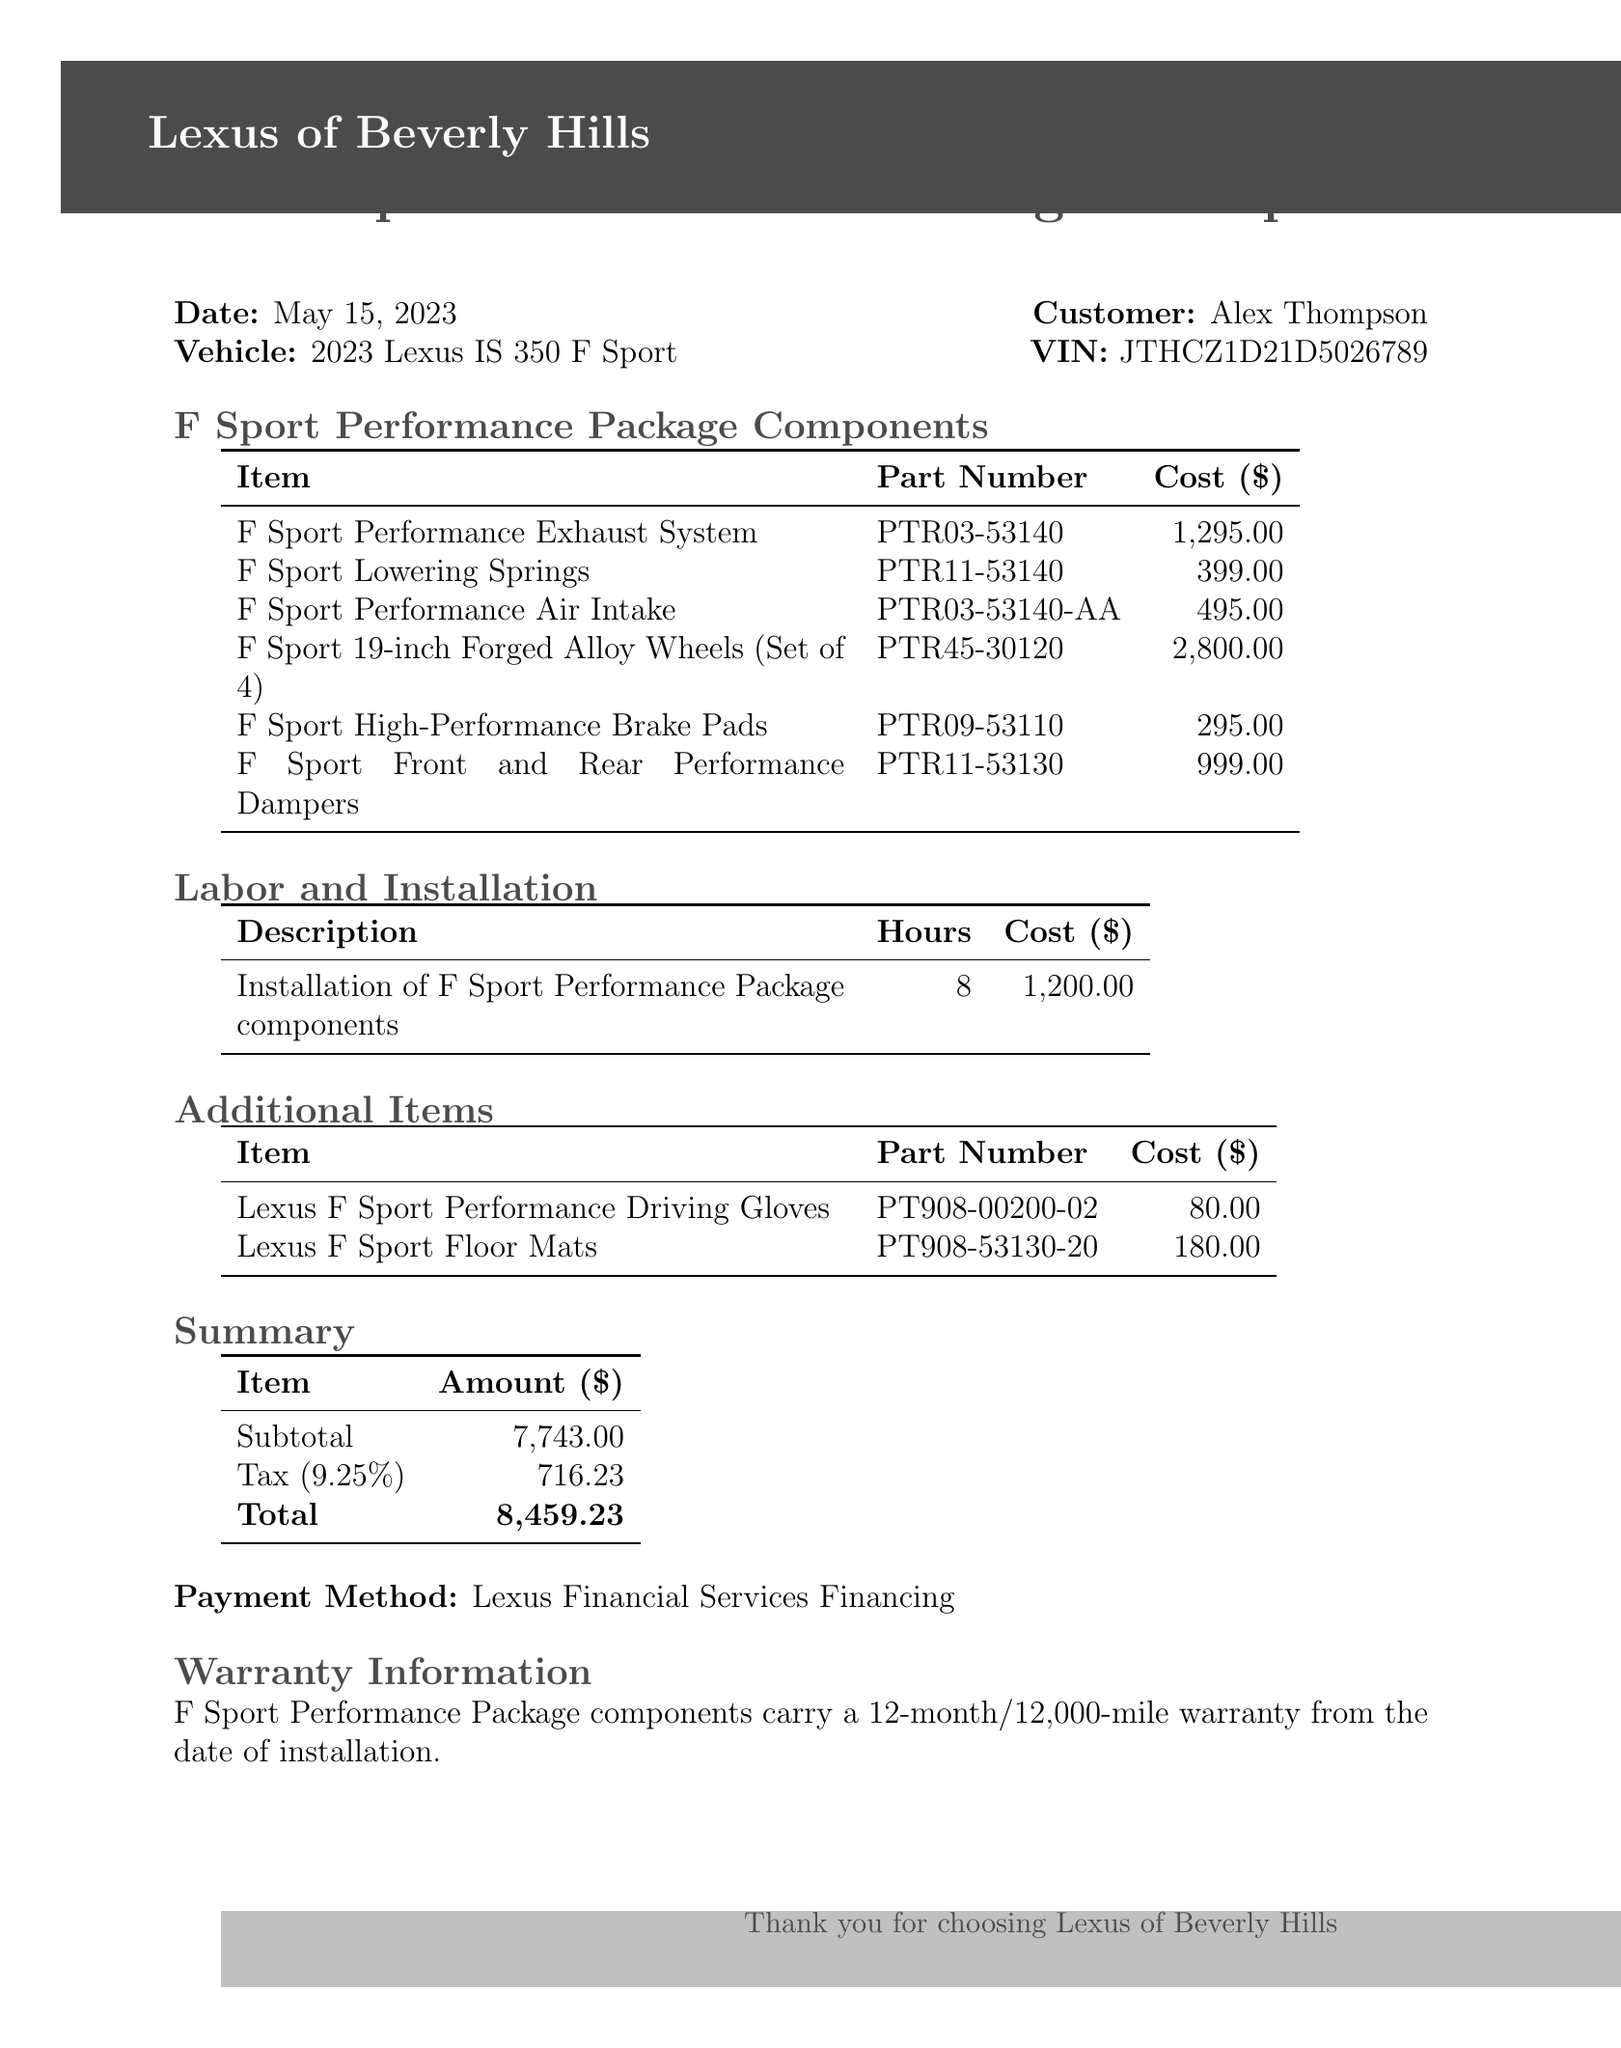What is the dealer name? The dealer name is prominently listed at the top of the document.
Answer: Lexus of Beverly Hills What is the date of the transaction? The date is included near the top of the receipt along with the customer information.
Answer: May 15, 2023 What is the total cost? The total cost is specified in the summary section at the end of the receipt.
Answer: 8,459.23 How many hours were spent on labor? The total labor hours are included in the labor and installation section.
Answer: 8 What is the cost of the F Sport Lowering Springs? The cost of this specific component is listed in the performance package components table.
Answer: 399.00 What part number corresponds to the F Sport Performance Air Intake? The part number is provided in the components section alongside each item.
Answer: PTR03-53140-AA What warranty is provided for the F Sport Performance Package components? The warranty information is mentioned in the warranty section at the end of the document.
Answer: 12-month/12,000-mile warranty How much did the Lexus F Sport Performance Driving Gloves cost? This item’s cost is specified in the additional items section of the receipt.
Answer: 80.00 What is the tax rate applied to the purchase? The tax rate is indicated in the summary section along with the other total amounts.
Answer: 9.25% 